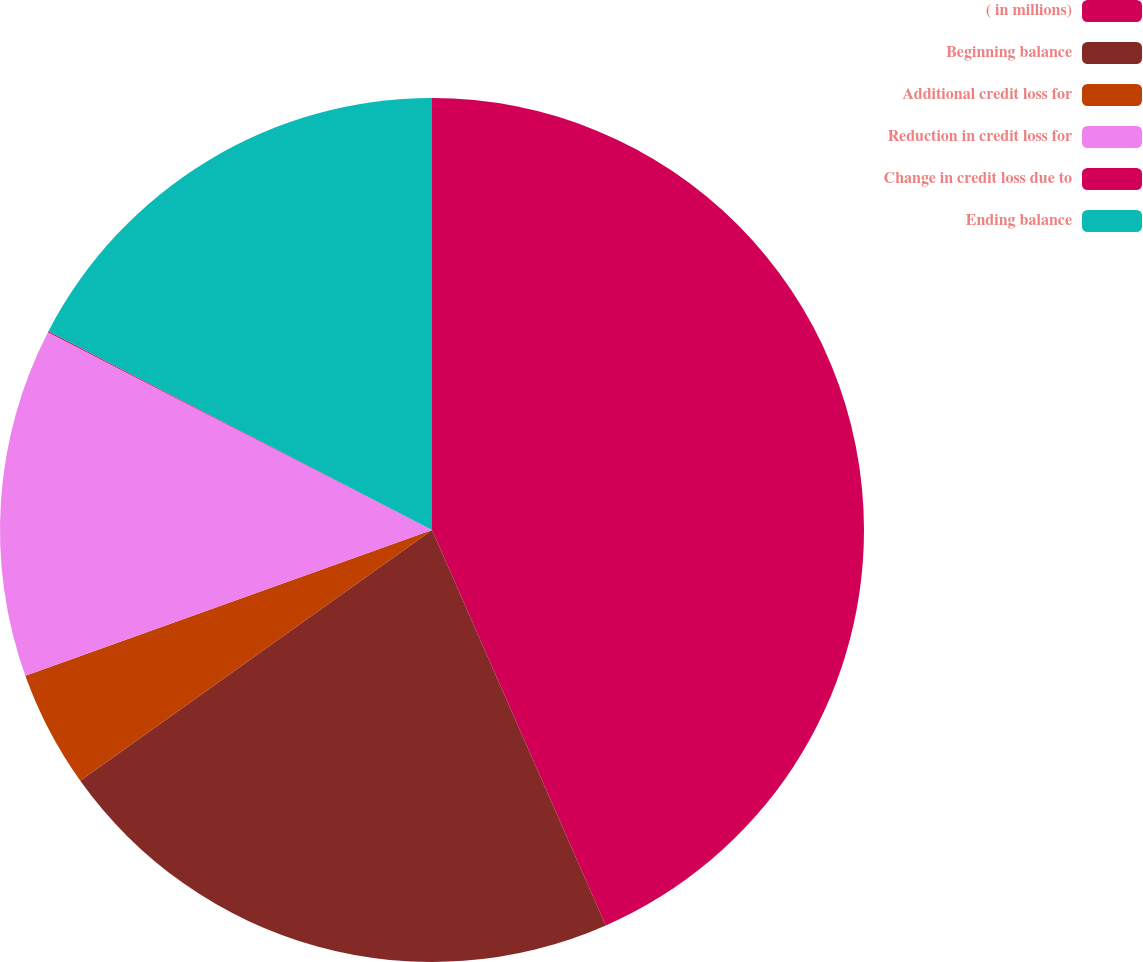<chart> <loc_0><loc_0><loc_500><loc_500><pie_chart><fcel>( in millions)<fcel>Beginning balance<fcel>Additional credit loss for<fcel>Reduction in credit loss for<fcel>Change in credit loss due to<fcel>Ending balance<nl><fcel>43.41%<fcel>21.73%<fcel>4.38%<fcel>13.05%<fcel>0.04%<fcel>17.39%<nl></chart> 